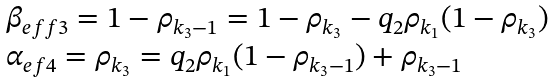Convert formula to latex. <formula><loc_0><loc_0><loc_500><loc_500>\begin{array} { l } \beta _ { e f f 3 } = 1 - \rho _ { k _ { 3 } - 1 } = 1 - \rho _ { k _ { 3 } } - q _ { 2 } \rho _ { k _ { 1 } } ( 1 - \rho _ { k _ { 3 } } ) \\ \alpha _ { e f 4 } = \rho _ { k _ { 3 } } = q _ { 2 } \rho _ { k _ { 1 } } ( 1 - \rho _ { k _ { 3 } - 1 } ) + \rho _ { k _ { 3 } - 1 } \end{array}</formula> 